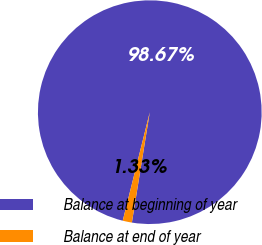Convert chart to OTSL. <chart><loc_0><loc_0><loc_500><loc_500><pie_chart><fcel>Balance at beginning of year<fcel>Balance at end of year<nl><fcel>98.67%<fcel>1.33%<nl></chart> 